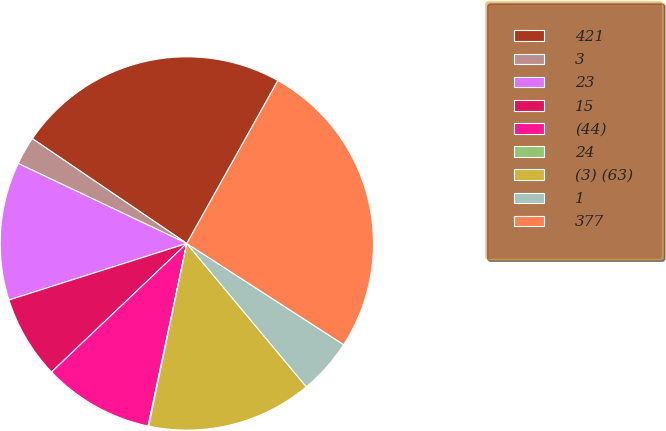<chart> <loc_0><loc_0><loc_500><loc_500><pie_chart><fcel>421<fcel>3<fcel>23<fcel>15<fcel>(44)<fcel>24<fcel>(3) (63)<fcel>1<fcel>377<nl><fcel>23.63%<fcel>2.44%<fcel>11.95%<fcel>7.2%<fcel>9.58%<fcel>0.06%<fcel>14.33%<fcel>4.82%<fcel>26.01%<nl></chart> 